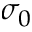<formula> <loc_0><loc_0><loc_500><loc_500>\sigma _ { 0 }</formula> 